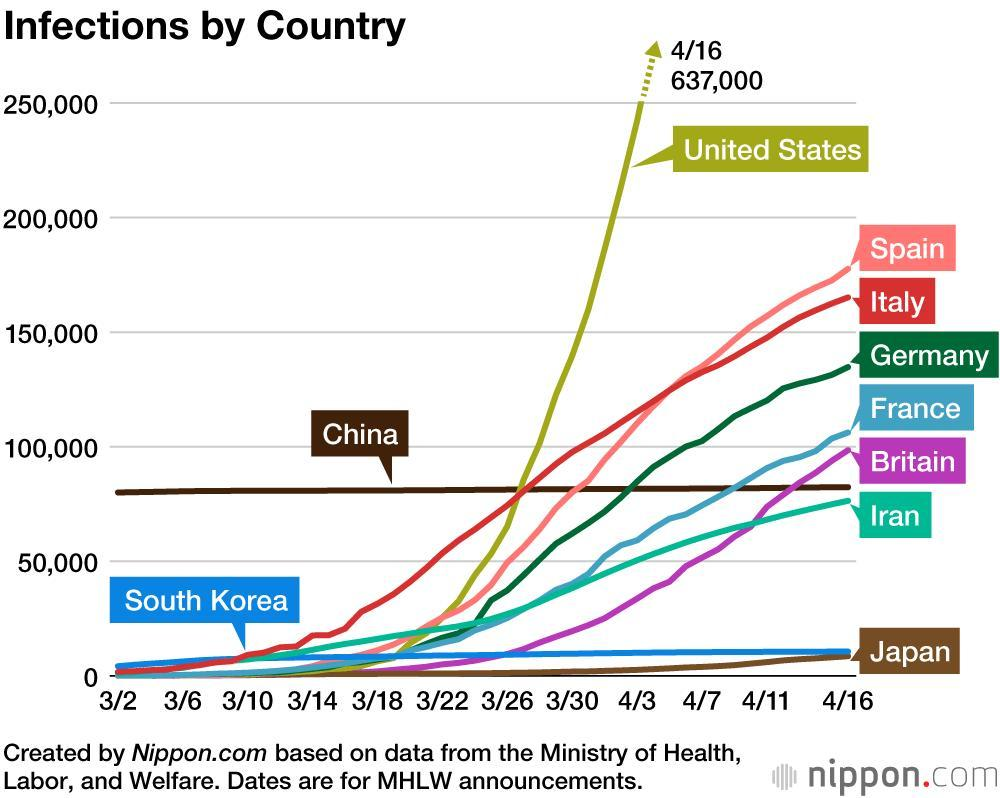What was the number of infections in United States on the 16th of April?
Answer the question with a short phrase. 637,000 Which country is second lowest the total number of infections? South Korea Which countries have infections below 50000? South Korea, Japan In which country has a number of infections been stable throughout? China Which country is second highest by the total number of Infections? Spain How many countries are plotted on the graph? 10 Which country has the highest rate of increase in infections, in the last week of March? United States Which colour is used to represent Germany - red, blue, green or yellow? Green 